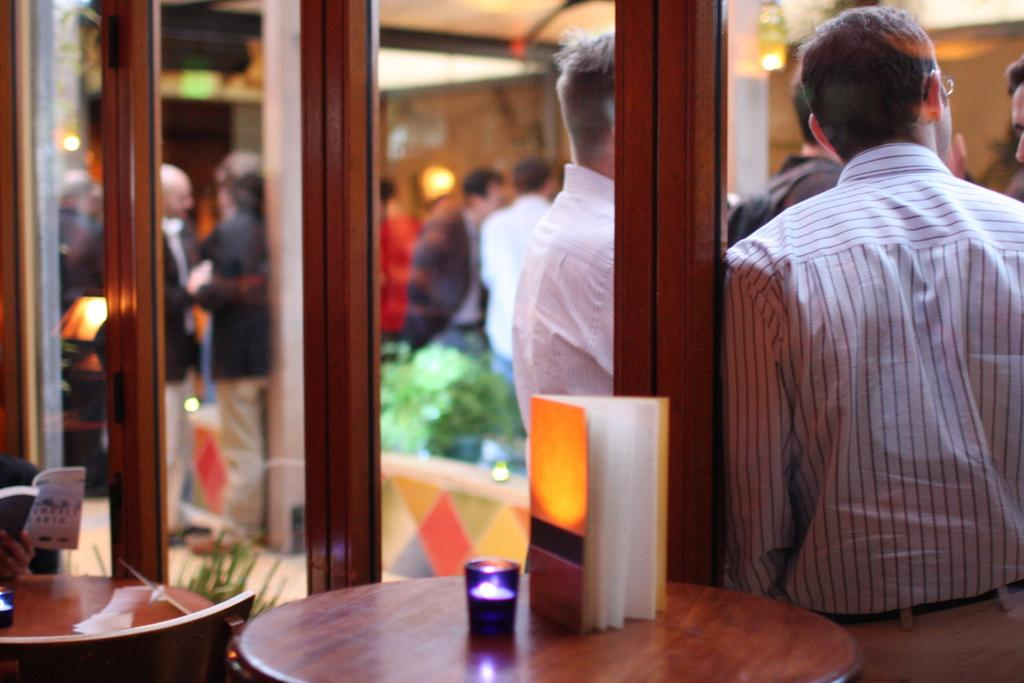What object is placed on the table in the image? There is a book on the table in the image. What type of door is visible in the image? There is a glass door in the image. Can you describe the people in the image? There is a group of people standing beside the glass door. Can you tell me how many ducks are swimming in the water near the glass door? There are no ducks or water visible in the image; it features a book on a table and a group of people standing beside a glass door. What type of art is displayed on the glass door? There is no art displayed on the glass door in the image. 